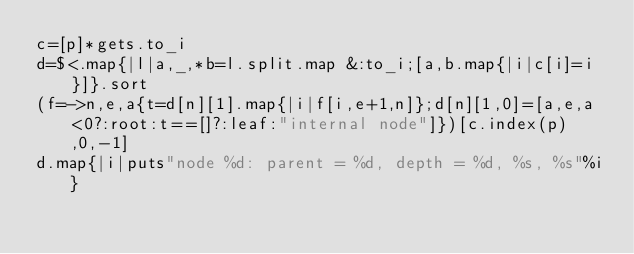<code> <loc_0><loc_0><loc_500><loc_500><_Ruby_>c=[p]*gets.to_i
d=$<.map{|l|a,_,*b=l.split.map &:to_i;[a,b.map{|i|c[i]=i}]}.sort
(f=->n,e,a{t=d[n][1].map{|i|f[i,e+1,n]};d[n][1,0]=[a,e,a<0?:root:t==[]?:leaf:"internal node"]})[c.index(p),0,-1]
d.map{|i|puts"node %d: parent = %d, depth = %d, %s, %s"%i}</code> 